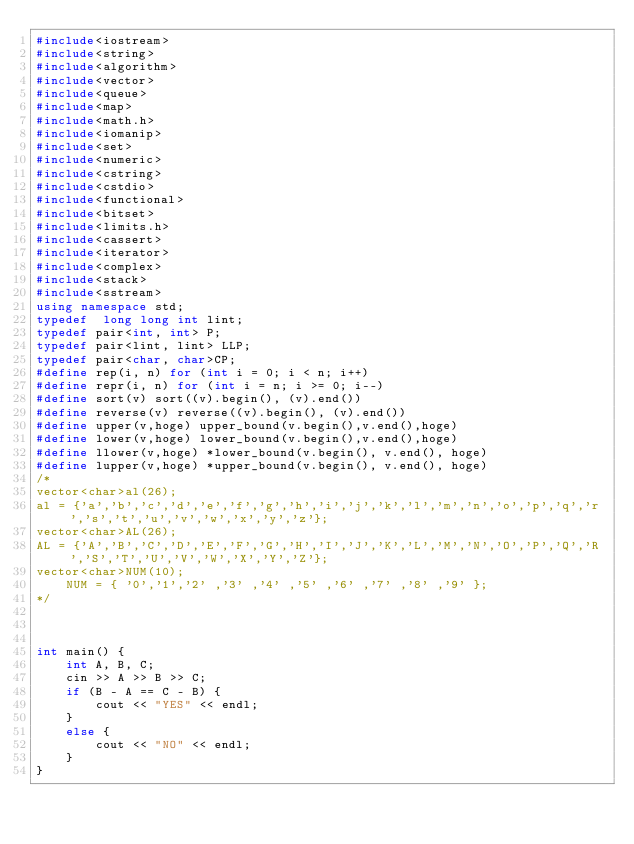Convert code to text. <code><loc_0><loc_0><loc_500><loc_500><_C++_>#include<iostream>
#include<string>
#include<algorithm>
#include<vector>
#include<queue>
#include<map>
#include<math.h>
#include<iomanip>
#include<set>
#include<numeric>
#include<cstring>
#include<cstdio>
#include<functional>
#include<bitset>
#include<limits.h>
#include<cassert>
#include<iterator>
#include<complex>
#include<stack>
#include<sstream>
using namespace std;
typedef  long long int lint;
typedef pair<int, int> P;
typedef pair<lint, lint> LLP;
typedef pair<char, char>CP;
#define rep(i, n) for (int i = 0; i < n; i++)
#define repr(i, n) for (int i = n; i >= 0; i--)
#define sort(v) sort((v).begin(), (v).end())
#define reverse(v) reverse((v).begin(), (v).end())
#define upper(v,hoge) upper_bound(v.begin(),v.end(),hoge)
#define lower(v,hoge) lower_bound(v.begin(),v.end(),hoge)
#define llower(v,hoge) *lower_bound(v.begin(), v.end(), hoge)
#define lupper(v,hoge) *upper_bound(v.begin(), v.end(), hoge)
/*
vector<char>al(26);
al = {'a','b','c','d','e','f','g','h','i','j','k','l','m','n','o','p','q','r','s','t','u','v','w','x','y','z'};
vector<char>AL(26);
AL = {'A','B','C','D','E','F','G','H','I','J','K','L','M','N','O','P','Q','R','S','T','U','V','W','X','Y','Z'};
vector<char>NUM(10);
	NUM = { '0','1','2' ,'3' ,'4' ,'5' ,'6' ,'7' ,'8' ,'9' };
*/



int main() {
	int A, B, C;
	cin >> A >> B >> C;
	if (B - A == C - B) {
		cout << "YES" << endl;
	}
	else {
		cout << "NO" << endl;
	}
}
</code> 